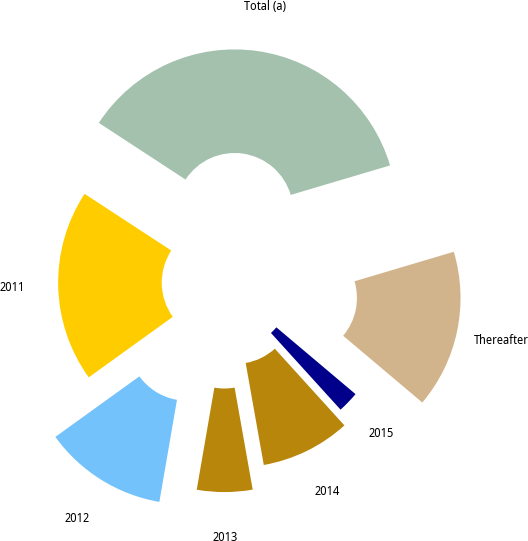Convert chart. <chart><loc_0><loc_0><loc_500><loc_500><pie_chart><fcel>2011<fcel>2012<fcel>2013<fcel>2014<fcel>2015<fcel>Thereafter<fcel>Total (a)<nl><fcel>19.15%<fcel>12.34%<fcel>5.52%<fcel>8.93%<fcel>2.12%<fcel>15.75%<fcel>36.19%<nl></chart> 